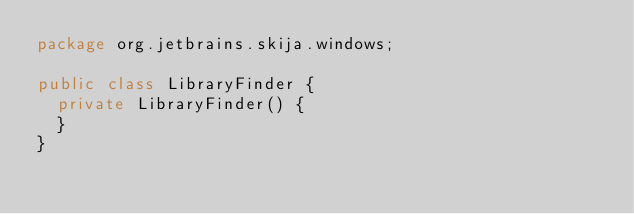<code> <loc_0><loc_0><loc_500><loc_500><_Java_>package org.jetbrains.skija.windows;

public class LibraryFinder {
  private LibraryFinder() {
  }
}</code> 